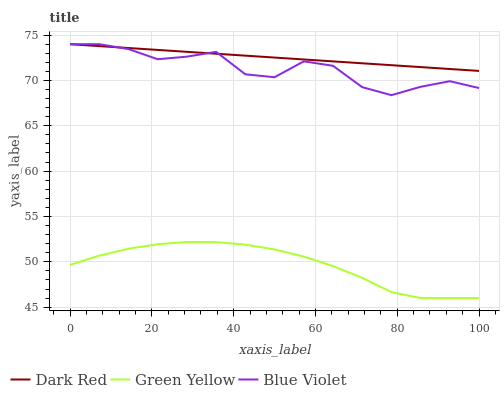Does Green Yellow have the minimum area under the curve?
Answer yes or no. Yes. Does Dark Red have the maximum area under the curve?
Answer yes or no. Yes. Does Blue Violet have the minimum area under the curve?
Answer yes or no. No. Does Blue Violet have the maximum area under the curve?
Answer yes or no. No. Is Dark Red the smoothest?
Answer yes or no. Yes. Is Blue Violet the roughest?
Answer yes or no. Yes. Is Green Yellow the smoothest?
Answer yes or no. No. Is Green Yellow the roughest?
Answer yes or no. No. Does Green Yellow have the lowest value?
Answer yes or no. Yes. Does Blue Violet have the lowest value?
Answer yes or no. No. Does Blue Violet have the highest value?
Answer yes or no. Yes. Does Green Yellow have the highest value?
Answer yes or no. No. Is Green Yellow less than Blue Violet?
Answer yes or no. Yes. Is Blue Violet greater than Green Yellow?
Answer yes or no. Yes. Does Dark Red intersect Blue Violet?
Answer yes or no. Yes. Is Dark Red less than Blue Violet?
Answer yes or no. No. Is Dark Red greater than Blue Violet?
Answer yes or no. No. Does Green Yellow intersect Blue Violet?
Answer yes or no. No. 